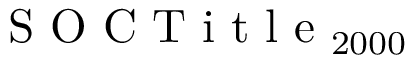Convert formula to latex. <formula><loc_0><loc_0><loc_500><loc_500>S O C T i t l e _ { 2 0 0 0 }</formula> 